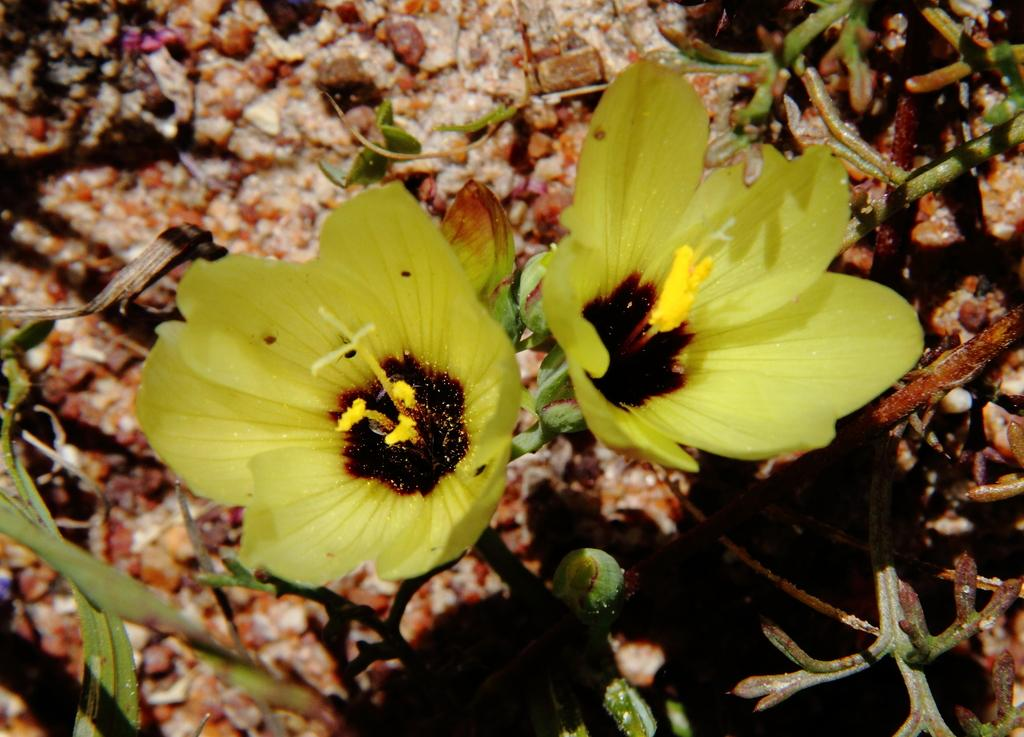What type of plants can be seen in the image? There are flowers in the image. What color are the flowers? The flowers are yellow in color. How many bags of oranges are visible in the image? There are no bags of oranges present in the image; it features yellow flowers. What type of magic is being performed with the flowers in the image? There is no magic being performed in the image; it simply shows yellow flowers. 